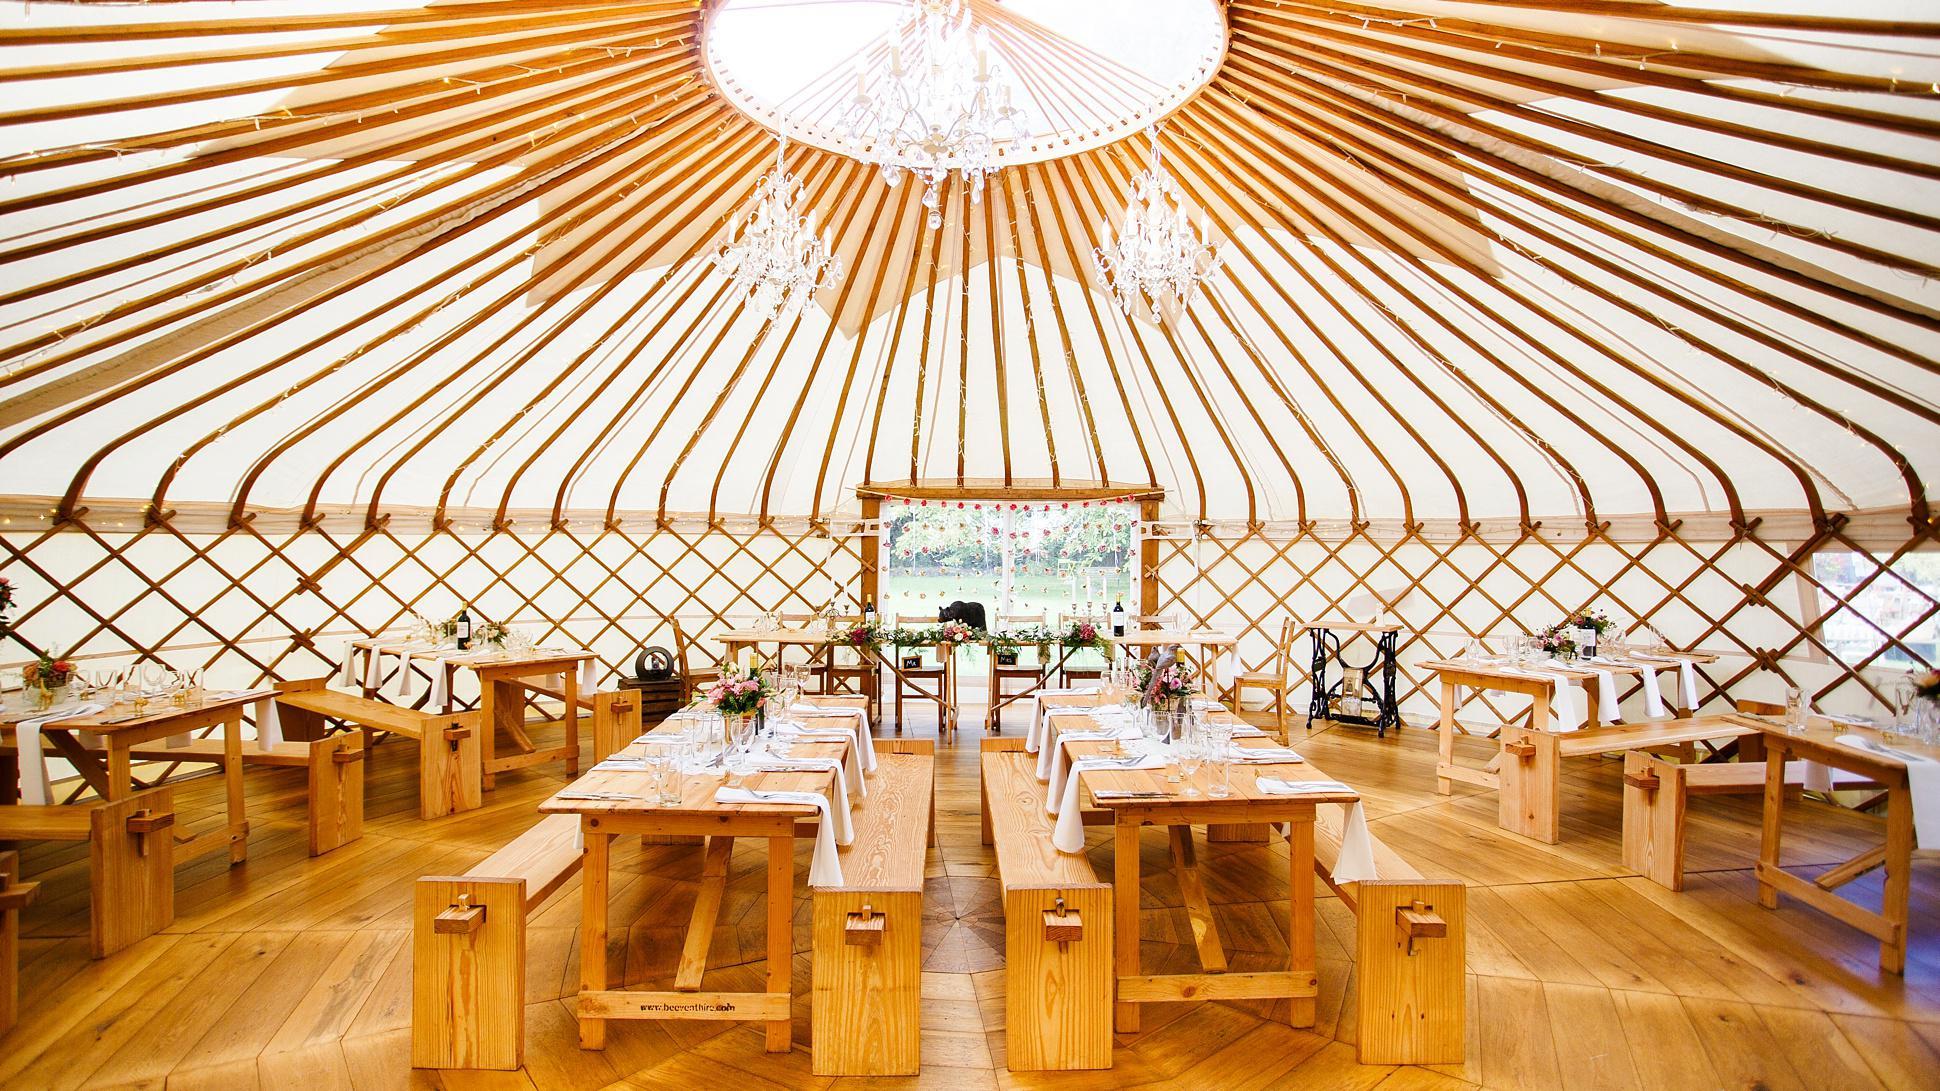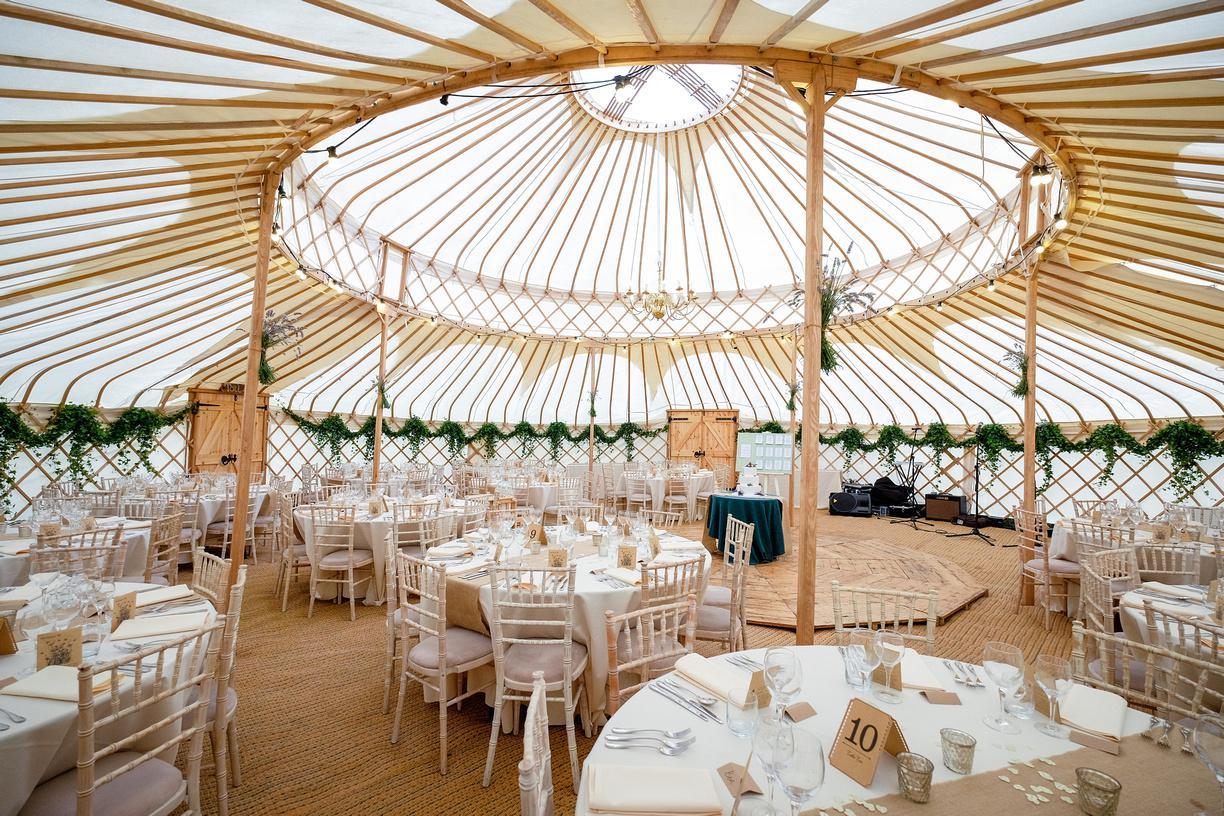The first image is the image on the left, the second image is the image on the right. Assess this claim about the two images: "There is one bed in the image on the right.". Correct or not? Answer yes or no. No. The first image is the image on the left, the second image is the image on the right. Analyze the images presented: Is the assertion "there are benches at the tables in the image on the left" valid? Answer yes or no. Yes. 